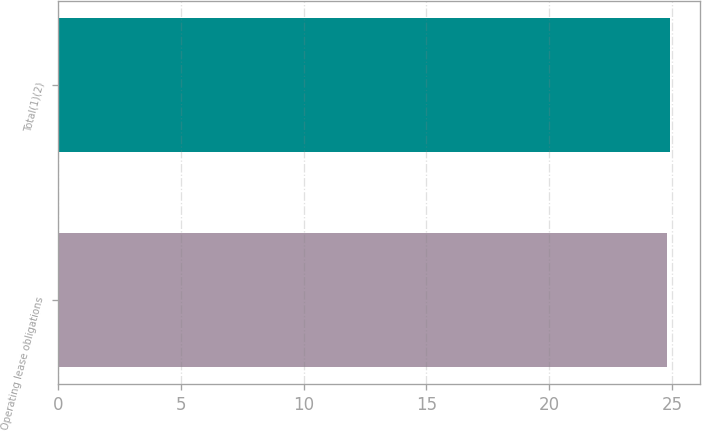<chart> <loc_0><loc_0><loc_500><loc_500><bar_chart><fcel>Operating lease obligations<fcel>Total(1)(2)<nl><fcel>24.8<fcel>24.9<nl></chart> 